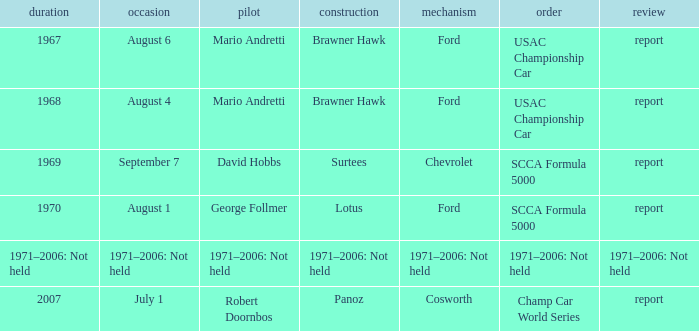Which engine is responsible for the USAC Championship Car? Ford, Ford. 